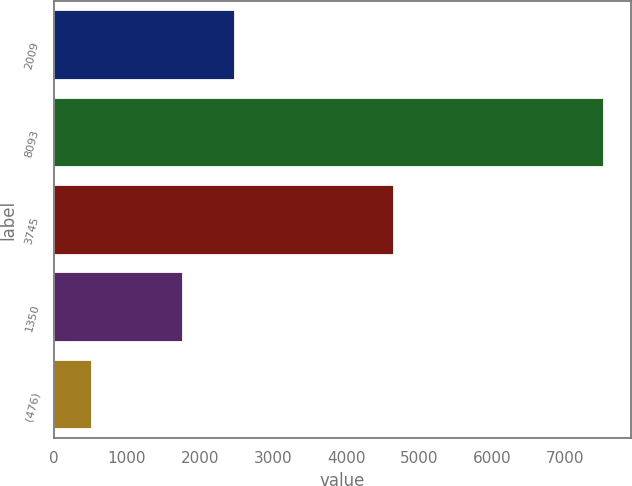Convert chart. <chart><loc_0><loc_0><loc_500><loc_500><bar_chart><fcel>2009<fcel>8093<fcel>3745<fcel>1350<fcel>(476)<nl><fcel>2472.8<fcel>7528<fcel>4651<fcel>1772<fcel>520<nl></chart> 